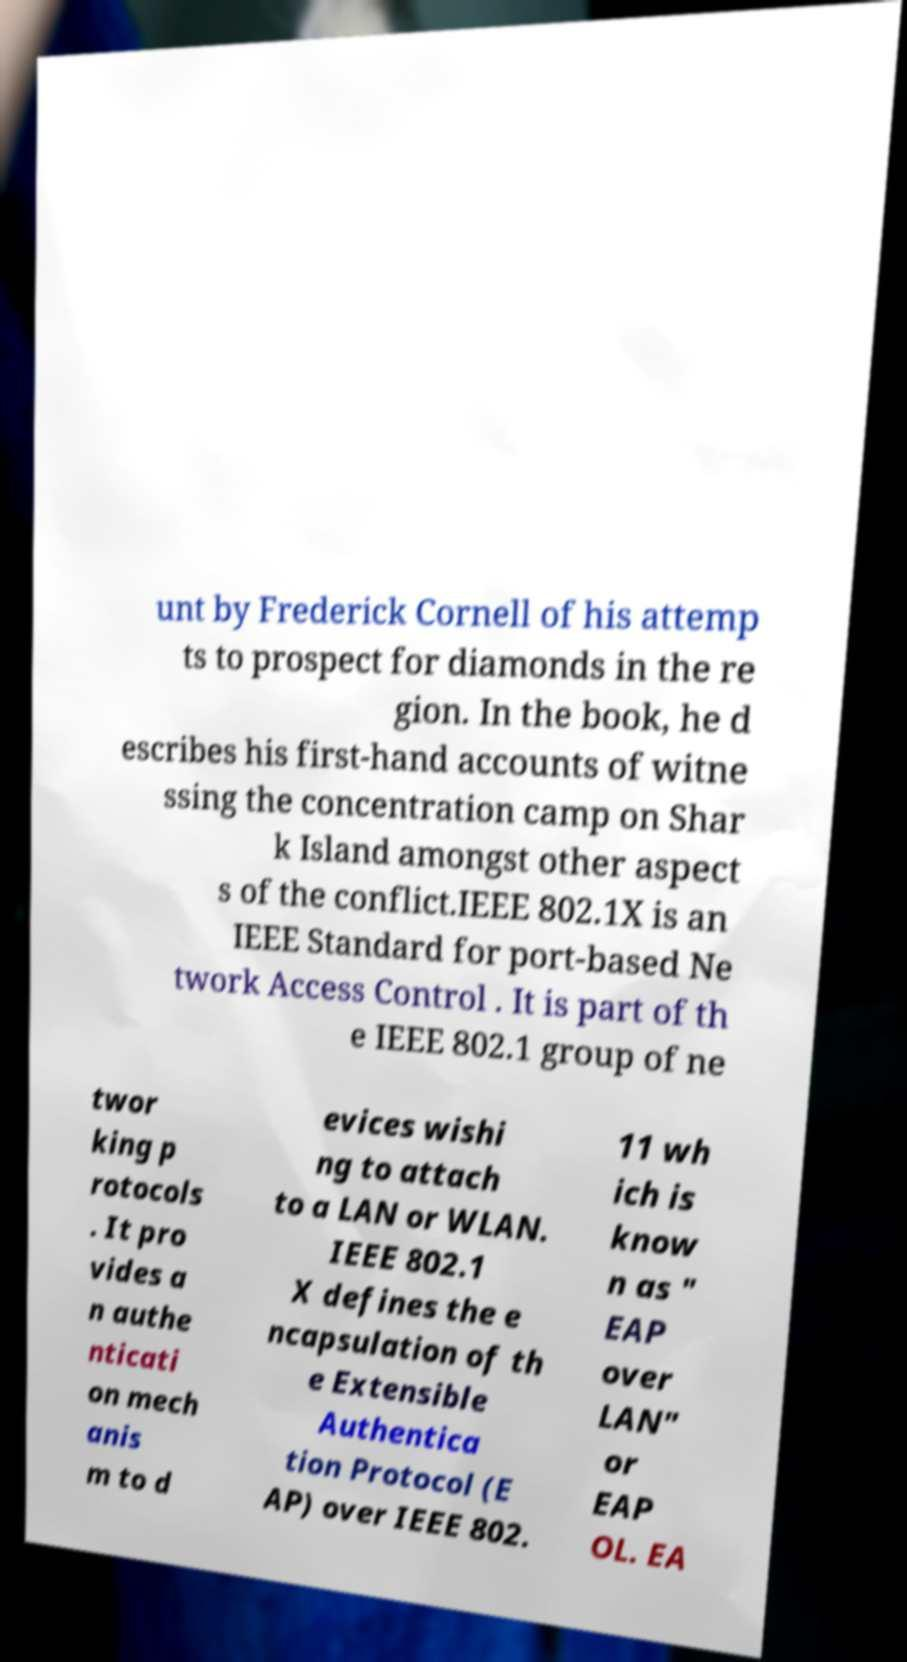What messages or text are displayed in this image? I need them in a readable, typed format. unt by Frederick Cornell of his attemp ts to prospect for diamonds in the re gion. In the book, he d escribes his first-hand accounts of witne ssing the concentration camp on Shar k Island amongst other aspect s of the conflict.IEEE 802.1X is an IEEE Standard for port-based Ne twork Access Control . It is part of th e IEEE 802.1 group of ne twor king p rotocols . It pro vides a n authe nticati on mech anis m to d evices wishi ng to attach to a LAN or WLAN. IEEE 802.1 X defines the e ncapsulation of th e Extensible Authentica tion Protocol (E AP) over IEEE 802. 11 wh ich is know n as " EAP over LAN" or EAP OL. EA 